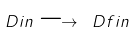<formula> <loc_0><loc_0><loc_500><loc_500>\ D i n \longrightarrow \ D f i n</formula> 